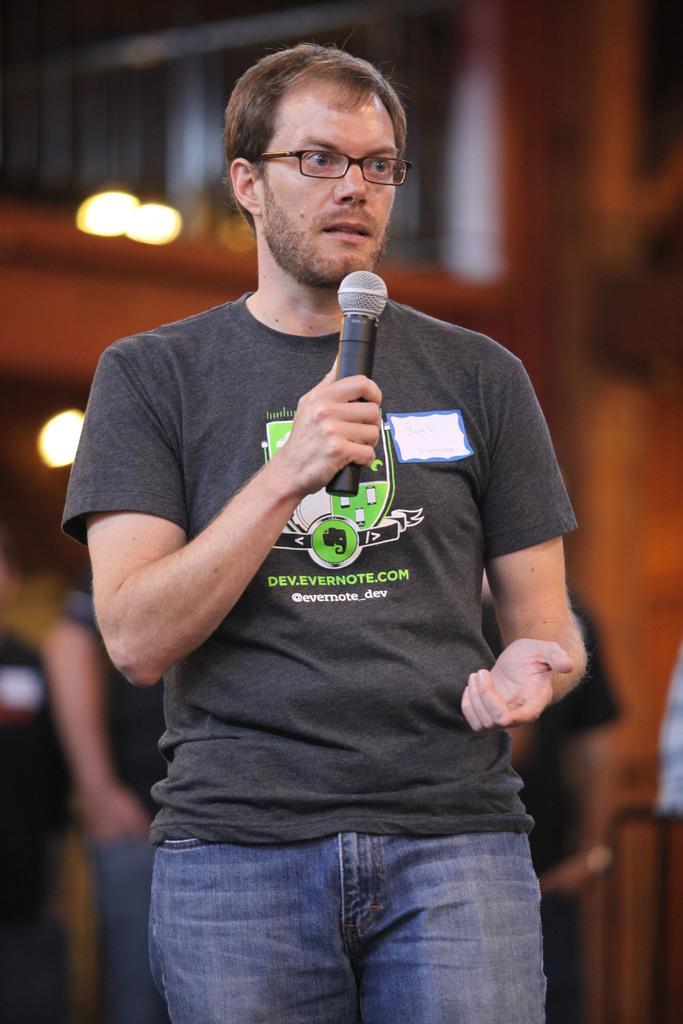How would you summarize this image in a sentence or two? This is a close up of a man standing, wearing clothes, spectacle and the man is holding a microphone in his hand. The background is blurred. 